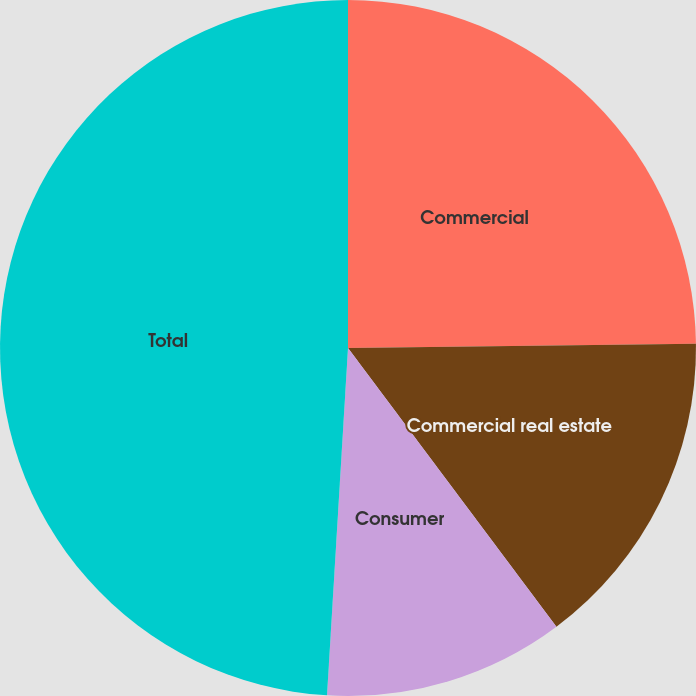<chart> <loc_0><loc_0><loc_500><loc_500><pie_chart><fcel>Commercial<fcel>Commercial real estate<fcel>Consumer<fcel>Total<nl><fcel>24.81%<fcel>14.97%<fcel>11.18%<fcel>49.04%<nl></chart> 